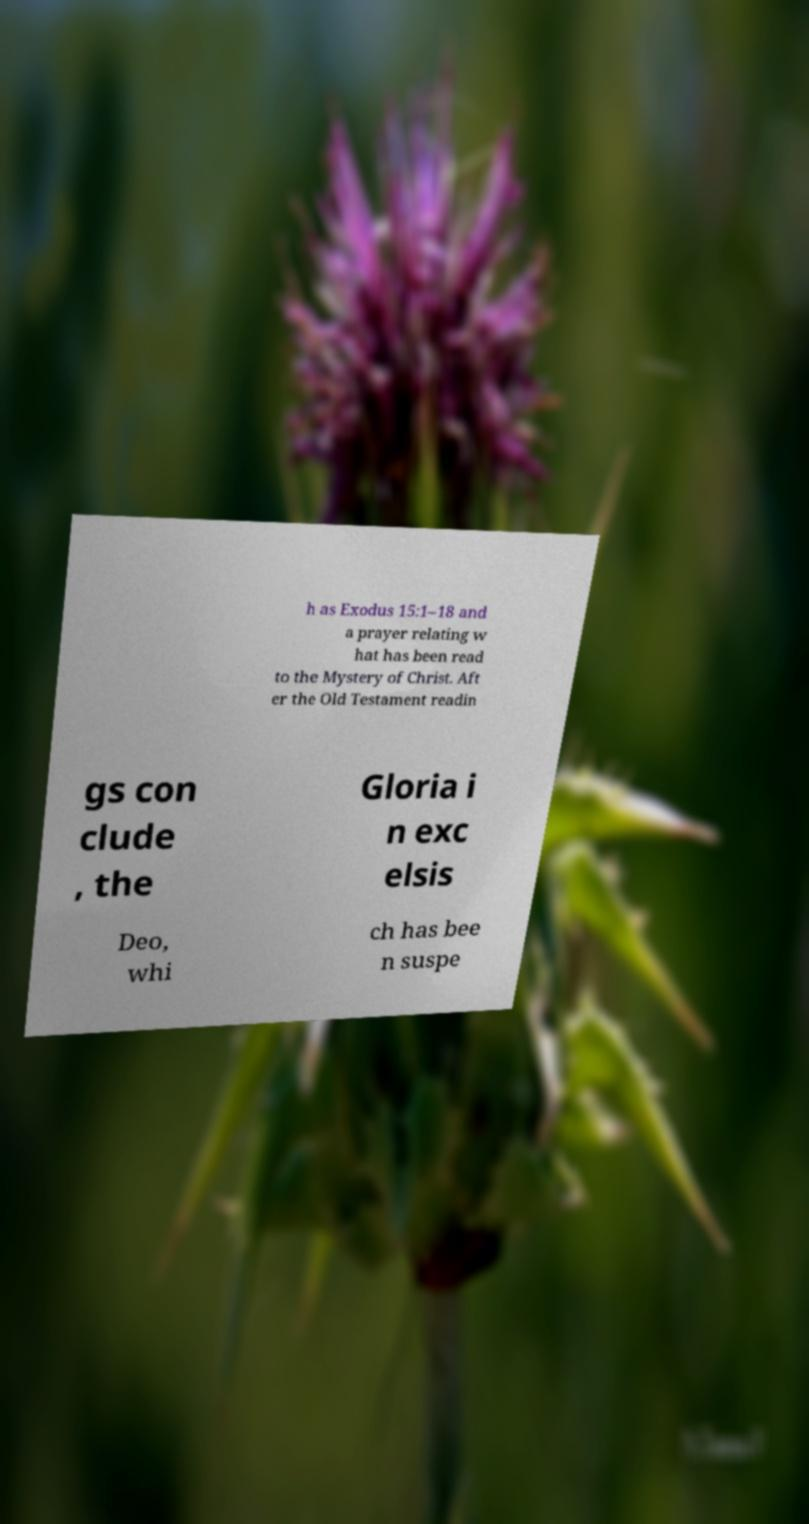There's text embedded in this image that I need extracted. Can you transcribe it verbatim? h as Exodus 15:1–18 and a prayer relating w hat has been read to the Mystery of Christ. Aft er the Old Testament readin gs con clude , the Gloria i n exc elsis Deo, whi ch has bee n suspe 